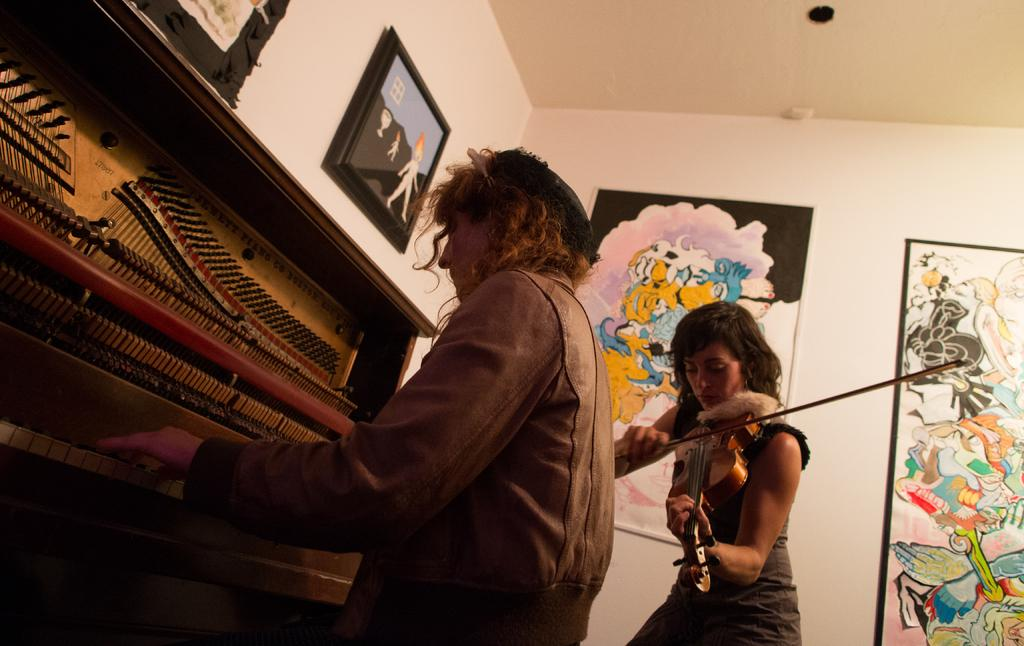What is the main activity of the person in the image? The person in the image is playing a piano. Are there any other people in the image? Yes, there is another person in the image. What is the second person doing? The second person is playing a violin. What type of toe disease can be seen on the person playing the piano? There is no mention of any toe disease in the image, and the person's feet are not visible. What kind of meal is being prepared by the person playing the piano? There is no indication of any meal preparation in the image; the person is playing the piano. 